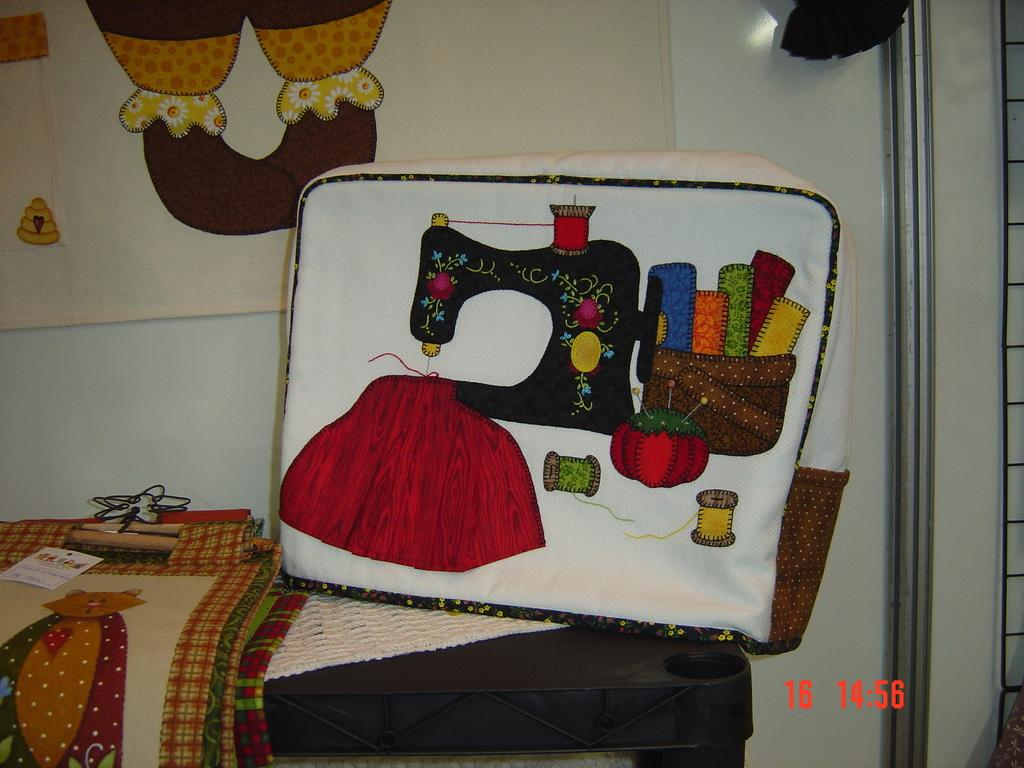What is the main object in the image? There is a table in the image. Where is the table located in relation to other objects? The table is in front of a wall. What items can be seen on the table? There are bags on the table. What is visible at the top of the image? There is a designed cloth at the top of the image. What is the condition of the celery in the image? There is no celery present in the image. Is there a camp visible in the image? There is no camp visible in the image. 